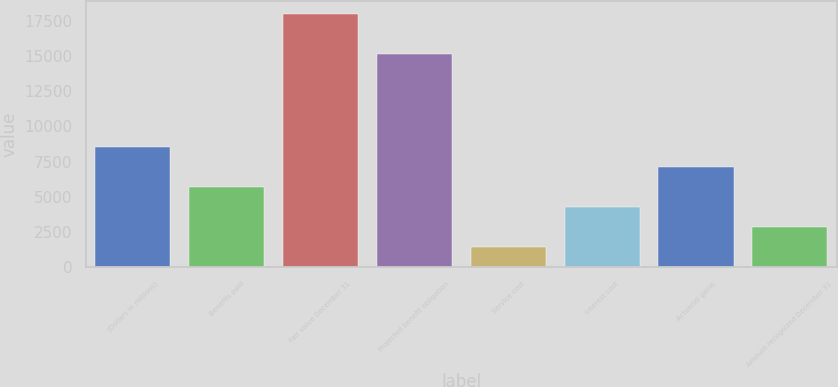Convert chart to OTSL. <chart><loc_0><loc_0><loc_500><loc_500><bar_chart><fcel>(Dollars in millions)<fcel>Benefits paid<fcel>Fair value December 31<fcel>Projected benefit obligation<fcel>Service cost<fcel>Interest cost<fcel>Actuarial gains<fcel>Amount recognized December 31<nl><fcel>8554.8<fcel>5705.2<fcel>17998.4<fcel>15148.8<fcel>1430.8<fcel>4280.4<fcel>7130<fcel>2855.6<nl></chart> 